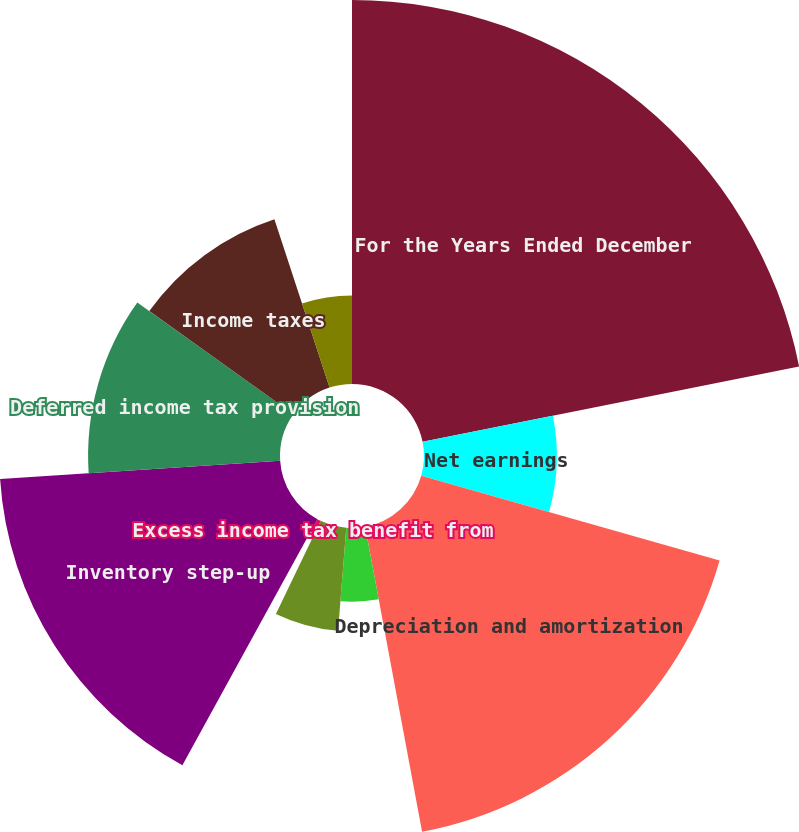Convert chart to OTSL. <chart><loc_0><loc_0><loc_500><loc_500><pie_chart><fcel>For the Years Ended December<fcel>Net earnings<fcel>Depreciation and amortization<fcel>Share-based compensation<fcel>Income tax benefit from stock<fcel>Excess income tax benefit from<fcel>Inventory step-up<fcel>Deferred income tax provision<fcel>Income taxes<fcel>Receivables<nl><fcel>21.85%<fcel>7.56%<fcel>17.65%<fcel>4.2%<fcel>5.88%<fcel>0.84%<fcel>15.97%<fcel>10.92%<fcel>10.08%<fcel>5.04%<nl></chart> 